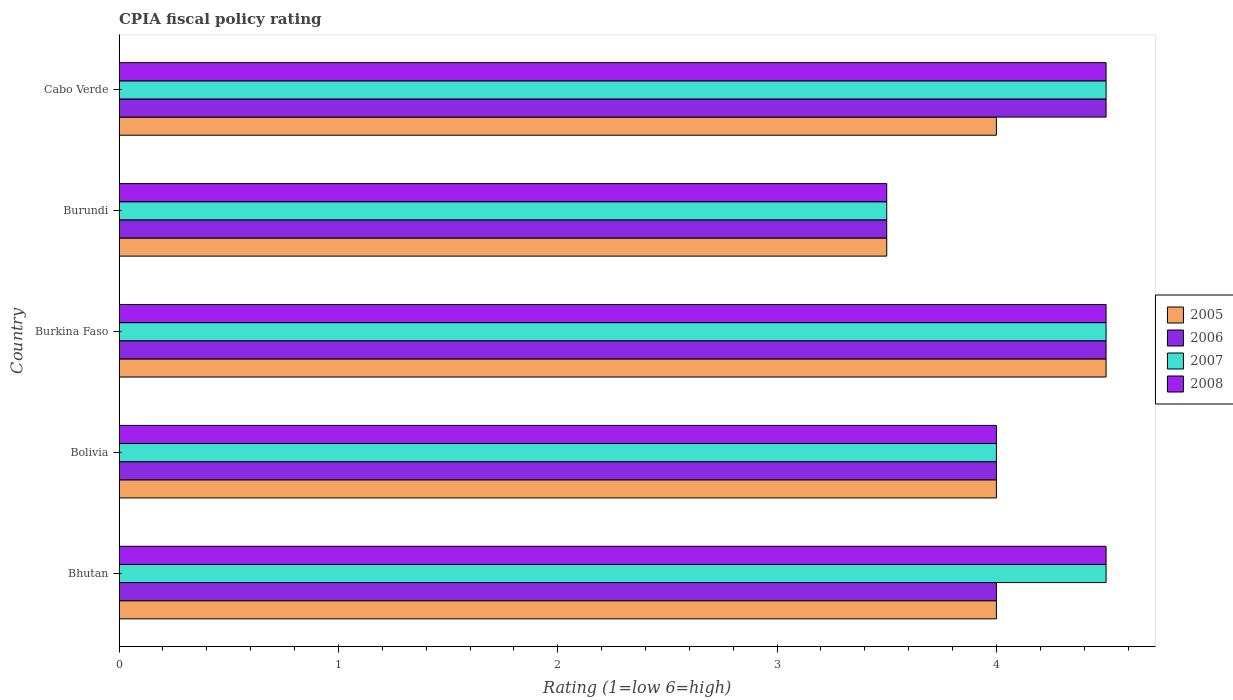How many different coloured bars are there?
Ensure brevity in your answer.  4. Are the number of bars on each tick of the Y-axis equal?
Offer a terse response. Yes. What is the label of the 1st group of bars from the top?
Your answer should be very brief. Cabo Verde. In which country was the CPIA rating in 2006 maximum?
Ensure brevity in your answer.  Burkina Faso. In which country was the CPIA rating in 2006 minimum?
Provide a succinct answer. Burundi. What is the total CPIA rating in 2005 in the graph?
Provide a short and direct response. 20. What is the difference between the CPIA rating in 2007 in Bolivia and the CPIA rating in 2008 in Bhutan?
Provide a succinct answer. -0.5. What is the difference between the CPIA rating in 2007 and CPIA rating in 2005 in Burkina Faso?
Offer a terse response. 0. In how many countries, is the CPIA rating in 2006 greater than 1.4 ?
Ensure brevity in your answer.  5. In how many countries, is the CPIA rating in 2005 greater than the average CPIA rating in 2005 taken over all countries?
Ensure brevity in your answer.  1. How many bars are there?
Offer a terse response. 20. What is the difference between two consecutive major ticks on the X-axis?
Provide a short and direct response. 1. Are the values on the major ticks of X-axis written in scientific E-notation?
Keep it short and to the point. No. What is the title of the graph?
Provide a succinct answer. CPIA fiscal policy rating. What is the label or title of the Y-axis?
Your response must be concise. Country. What is the Rating (1=low 6=high) in 2007 in Bhutan?
Keep it short and to the point. 4.5. What is the Rating (1=low 6=high) of 2006 in Bolivia?
Provide a succinct answer. 4. What is the Rating (1=low 6=high) of 2007 in Bolivia?
Your answer should be very brief. 4. What is the Rating (1=low 6=high) in 2005 in Burkina Faso?
Your answer should be compact. 4.5. What is the Rating (1=low 6=high) of 2006 in Burkina Faso?
Offer a very short reply. 4.5. What is the Rating (1=low 6=high) in 2006 in Burundi?
Provide a succinct answer. 3.5. What is the Rating (1=low 6=high) in 2007 in Burundi?
Offer a very short reply. 3.5. What is the Rating (1=low 6=high) in 2008 in Burundi?
Provide a short and direct response. 3.5. What is the Rating (1=low 6=high) of 2007 in Cabo Verde?
Provide a succinct answer. 4.5. Across all countries, what is the maximum Rating (1=low 6=high) in 2006?
Offer a terse response. 4.5. Across all countries, what is the maximum Rating (1=low 6=high) in 2007?
Provide a short and direct response. 4.5. Across all countries, what is the minimum Rating (1=low 6=high) of 2005?
Keep it short and to the point. 3.5. Across all countries, what is the minimum Rating (1=low 6=high) in 2006?
Offer a very short reply. 3.5. What is the total Rating (1=low 6=high) in 2007 in the graph?
Your answer should be very brief. 21. What is the difference between the Rating (1=low 6=high) of 2005 in Bhutan and that in Bolivia?
Make the answer very short. 0. What is the difference between the Rating (1=low 6=high) in 2008 in Bhutan and that in Bolivia?
Your answer should be very brief. 0.5. What is the difference between the Rating (1=low 6=high) in 2006 in Bhutan and that in Burkina Faso?
Provide a succinct answer. -0.5. What is the difference between the Rating (1=low 6=high) of 2008 in Bhutan and that in Burkina Faso?
Provide a succinct answer. 0. What is the difference between the Rating (1=low 6=high) in 2005 in Bhutan and that in Burundi?
Your response must be concise. 0.5. What is the difference between the Rating (1=low 6=high) in 2008 in Bhutan and that in Burundi?
Offer a very short reply. 1. What is the difference between the Rating (1=low 6=high) of 2007 in Bhutan and that in Cabo Verde?
Give a very brief answer. 0. What is the difference between the Rating (1=low 6=high) of 2007 in Bolivia and that in Burkina Faso?
Provide a short and direct response. -0.5. What is the difference between the Rating (1=low 6=high) in 2008 in Bolivia and that in Burkina Faso?
Provide a short and direct response. -0.5. What is the difference between the Rating (1=low 6=high) of 2006 in Bolivia and that in Burundi?
Provide a short and direct response. 0.5. What is the difference between the Rating (1=low 6=high) in 2007 in Bolivia and that in Burundi?
Make the answer very short. 0.5. What is the difference between the Rating (1=low 6=high) of 2008 in Bolivia and that in Burundi?
Your answer should be compact. 0.5. What is the difference between the Rating (1=low 6=high) in 2006 in Bolivia and that in Cabo Verde?
Offer a terse response. -0.5. What is the difference between the Rating (1=low 6=high) of 2008 in Bolivia and that in Cabo Verde?
Your response must be concise. -0.5. What is the difference between the Rating (1=low 6=high) of 2007 in Burkina Faso and that in Burundi?
Your answer should be compact. 1. What is the difference between the Rating (1=low 6=high) of 2005 in Burundi and that in Cabo Verde?
Your answer should be compact. -0.5. What is the difference between the Rating (1=low 6=high) in 2006 in Burundi and that in Cabo Verde?
Provide a short and direct response. -1. What is the difference between the Rating (1=low 6=high) in 2005 in Bhutan and the Rating (1=low 6=high) in 2006 in Bolivia?
Your answer should be very brief. 0. What is the difference between the Rating (1=low 6=high) in 2007 in Bhutan and the Rating (1=low 6=high) in 2008 in Bolivia?
Your answer should be very brief. 0.5. What is the difference between the Rating (1=low 6=high) in 2005 in Bhutan and the Rating (1=low 6=high) in 2007 in Burkina Faso?
Keep it short and to the point. -0.5. What is the difference between the Rating (1=low 6=high) of 2005 in Bhutan and the Rating (1=low 6=high) of 2008 in Burkina Faso?
Offer a very short reply. -0.5. What is the difference between the Rating (1=low 6=high) of 2007 in Bhutan and the Rating (1=low 6=high) of 2008 in Burkina Faso?
Your answer should be very brief. 0. What is the difference between the Rating (1=low 6=high) of 2005 in Bhutan and the Rating (1=low 6=high) of 2006 in Burundi?
Keep it short and to the point. 0.5. What is the difference between the Rating (1=low 6=high) in 2005 in Bhutan and the Rating (1=low 6=high) in 2007 in Burundi?
Ensure brevity in your answer.  0.5. What is the difference between the Rating (1=low 6=high) of 2005 in Bhutan and the Rating (1=low 6=high) of 2008 in Burundi?
Keep it short and to the point. 0.5. What is the difference between the Rating (1=low 6=high) in 2006 in Bhutan and the Rating (1=low 6=high) in 2007 in Burundi?
Make the answer very short. 0.5. What is the difference between the Rating (1=low 6=high) in 2005 in Bhutan and the Rating (1=low 6=high) in 2007 in Cabo Verde?
Offer a very short reply. -0.5. What is the difference between the Rating (1=low 6=high) in 2005 in Bhutan and the Rating (1=low 6=high) in 2008 in Cabo Verde?
Ensure brevity in your answer.  -0.5. What is the difference between the Rating (1=low 6=high) in 2006 in Bhutan and the Rating (1=low 6=high) in 2007 in Cabo Verde?
Make the answer very short. -0.5. What is the difference between the Rating (1=low 6=high) in 2006 in Bhutan and the Rating (1=low 6=high) in 2008 in Cabo Verde?
Provide a succinct answer. -0.5. What is the difference between the Rating (1=low 6=high) in 2007 in Bhutan and the Rating (1=low 6=high) in 2008 in Cabo Verde?
Your answer should be very brief. 0. What is the difference between the Rating (1=low 6=high) in 2005 in Bolivia and the Rating (1=low 6=high) in 2007 in Burkina Faso?
Your answer should be compact. -0.5. What is the difference between the Rating (1=low 6=high) of 2005 in Bolivia and the Rating (1=low 6=high) of 2008 in Burkina Faso?
Make the answer very short. -0.5. What is the difference between the Rating (1=low 6=high) in 2007 in Bolivia and the Rating (1=low 6=high) in 2008 in Burkina Faso?
Keep it short and to the point. -0.5. What is the difference between the Rating (1=low 6=high) in 2005 in Bolivia and the Rating (1=low 6=high) in 2006 in Burundi?
Provide a succinct answer. 0.5. What is the difference between the Rating (1=low 6=high) in 2006 in Bolivia and the Rating (1=low 6=high) in 2008 in Burundi?
Provide a short and direct response. 0.5. What is the difference between the Rating (1=low 6=high) of 2007 in Bolivia and the Rating (1=low 6=high) of 2008 in Burundi?
Provide a succinct answer. 0.5. What is the difference between the Rating (1=low 6=high) of 2005 in Bolivia and the Rating (1=low 6=high) of 2006 in Cabo Verde?
Make the answer very short. -0.5. What is the difference between the Rating (1=low 6=high) in 2005 in Bolivia and the Rating (1=low 6=high) in 2008 in Cabo Verde?
Give a very brief answer. -0.5. What is the difference between the Rating (1=low 6=high) of 2006 in Bolivia and the Rating (1=low 6=high) of 2007 in Cabo Verde?
Give a very brief answer. -0.5. What is the difference between the Rating (1=low 6=high) in 2006 in Bolivia and the Rating (1=low 6=high) in 2008 in Cabo Verde?
Keep it short and to the point. -0.5. What is the difference between the Rating (1=low 6=high) in 2005 in Burkina Faso and the Rating (1=low 6=high) in 2007 in Burundi?
Offer a terse response. 1. What is the difference between the Rating (1=low 6=high) of 2006 in Burkina Faso and the Rating (1=low 6=high) of 2007 in Burundi?
Offer a very short reply. 1. What is the difference between the Rating (1=low 6=high) in 2007 in Burkina Faso and the Rating (1=low 6=high) in 2008 in Burundi?
Your response must be concise. 1. What is the difference between the Rating (1=low 6=high) in 2005 in Burkina Faso and the Rating (1=low 6=high) in 2007 in Cabo Verde?
Give a very brief answer. 0. What is the difference between the Rating (1=low 6=high) in 2005 in Burkina Faso and the Rating (1=low 6=high) in 2008 in Cabo Verde?
Your response must be concise. 0. What is the difference between the Rating (1=low 6=high) of 2006 in Burkina Faso and the Rating (1=low 6=high) of 2007 in Cabo Verde?
Provide a succinct answer. 0. What is the difference between the Rating (1=low 6=high) in 2006 in Burkina Faso and the Rating (1=low 6=high) in 2008 in Cabo Verde?
Provide a succinct answer. 0. What is the difference between the Rating (1=low 6=high) in 2007 in Burkina Faso and the Rating (1=low 6=high) in 2008 in Cabo Verde?
Ensure brevity in your answer.  0. What is the difference between the Rating (1=low 6=high) in 2005 in Burundi and the Rating (1=low 6=high) in 2006 in Cabo Verde?
Offer a terse response. -1. What is the difference between the Rating (1=low 6=high) of 2006 in Burundi and the Rating (1=low 6=high) of 2008 in Cabo Verde?
Your answer should be compact. -1. What is the average Rating (1=low 6=high) of 2005 per country?
Your response must be concise. 4. What is the average Rating (1=low 6=high) of 2006 per country?
Provide a succinct answer. 4.1. What is the average Rating (1=low 6=high) in 2007 per country?
Provide a succinct answer. 4.2. What is the average Rating (1=low 6=high) in 2008 per country?
Give a very brief answer. 4.2. What is the difference between the Rating (1=low 6=high) in 2005 and Rating (1=low 6=high) in 2006 in Bhutan?
Provide a short and direct response. 0. What is the difference between the Rating (1=low 6=high) in 2006 and Rating (1=low 6=high) in 2008 in Bhutan?
Your answer should be very brief. -0.5. What is the difference between the Rating (1=low 6=high) of 2007 and Rating (1=low 6=high) of 2008 in Bhutan?
Provide a succinct answer. 0. What is the difference between the Rating (1=low 6=high) of 2005 and Rating (1=low 6=high) of 2006 in Bolivia?
Provide a short and direct response. 0. What is the difference between the Rating (1=low 6=high) in 2005 and Rating (1=low 6=high) in 2008 in Bolivia?
Your answer should be compact. 0. What is the difference between the Rating (1=low 6=high) of 2006 and Rating (1=low 6=high) of 2008 in Bolivia?
Keep it short and to the point. 0. What is the difference between the Rating (1=low 6=high) in 2007 and Rating (1=low 6=high) in 2008 in Bolivia?
Give a very brief answer. 0. What is the difference between the Rating (1=low 6=high) in 2007 and Rating (1=low 6=high) in 2008 in Burkina Faso?
Offer a very short reply. 0. What is the difference between the Rating (1=low 6=high) of 2005 and Rating (1=low 6=high) of 2006 in Burundi?
Your answer should be compact. 0. What is the difference between the Rating (1=low 6=high) in 2006 and Rating (1=low 6=high) in 2007 in Burundi?
Your answer should be compact. 0. What is the difference between the Rating (1=low 6=high) in 2006 and Rating (1=low 6=high) in 2008 in Burundi?
Keep it short and to the point. 0. What is the difference between the Rating (1=low 6=high) of 2005 and Rating (1=low 6=high) of 2006 in Cabo Verde?
Provide a succinct answer. -0.5. What is the difference between the Rating (1=low 6=high) of 2005 and Rating (1=low 6=high) of 2007 in Cabo Verde?
Ensure brevity in your answer.  -0.5. What is the difference between the Rating (1=low 6=high) in 2006 and Rating (1=low 6=high) in 2007 in Cabo Verde?
Offer a terse response. 0. What is the difference between the Rating (1=low 6=high) in 2006 and Rating (1=low 6=high) in 2008 in Cabo Verde?
Provide a succinct answer. 0. What is the difference between the Rating (1=low 6=high) in 2007 and Rating (1=low 6=high) in 2008 in Cabo Verde?
Keep it short and to the point. 0. What is the ratio of the Rating (1=low 6=high) of 2006 in Bhutan to that in Bolivia?
Offer a terse response. 1. What is the ratio of the Rating (1=low 6=high) of 2007 in Bhutan to that in Bolivia?
Your answer should be compact. 1.12. What is the ratio of the Rating (1=low 6=high) of 2005 in Bhutan to that in Burkina Faso?
Provide a short and direct response. 0.89. What is the ratio of the Rating (1=low 6=high) in 2006 in Bhutan to that in Burkina Faso?
Make the answer very short. 0.89. What is the ratio of the Rating (1=low 6=high) of 2008 in Bhutan to that in Burkina Faso?
Your answer should be very brief. 1. What is the ratio of the Rating (1=low 6=high) of 2005 in Bhutan to that in Burundi?
Provide a short and direct response. 1.14. What is the ratio of the Rating (1=low 6=high) in 2006 in Bhutan to that in Burundi?
Give a very brief answer. 1.14. What is the ratio of the Rating (1=low 6=high) of 2008 in Bhutan to that in Burundi?
Give a very brief answer. 1.29. What is the ratio of the Rating (1=low 6=high) of 2007 in Bolivia to that in Burkina Faso?
Provide a short and direct response. 0.89. What is the ratio of the Rating (1=low 6=high) in 2005 in Bolivia to that in Burundi?
Make the answer very short. 1.14. What is the ratio of the Rating (1=low 6=high) in 2008 in Bolivia to that in Burundi?
Your answer should be very brief. 1.14. What is the ratio of the Rating (1=low 6=high) of 2006 in Bolivia to that in Cabo Verde?
Your answer should be compact. 0.89. What is the ratio of the Rating (1=low 6=high) of 2007 in Bolivia to that in Cabo Verde?
Offer a terse response. 0.89. What is the ratio of the Rating (1=low 6=high) of 2006 in Burkina Faso to that in Burundi?
Your answer should be compact. 1.29. What is the ratio of the Rating (1=low 6=high) in 2008 in Burkina Faso to that in Burundi?
Your answer should be compact. 1.29. What is the ratio of the Rating (1=low 6=high) in 2005 in Burkina Faso to that in Cabo Verde?
Your answer should be compact. 1.12. What is the ratio of the Rating (1=low 6=high) of 2007 in Burkina Faso to that in Cabo Verde?
Offer a very short reply. 1. What is the ratio of the Rating (1=low 6=high) in 2008 in Burundi to that in Cabo Verde?
Offer a terse response. 0.78. What is the difference between the highest and the second highest Rating (1=low 6=high) of 2005?
Provide a succinct answer. 0.5. What is the difference between the highest and the second highest Rating (1=low 6=high) of 2006?
Your response must be concise. 0. What is the difference between the highest and the second highest Rating (1=low 6=high) of 2007?
Offer a terse response. 0. What is the difference between the highest and the second highest Rating (1=low 6=high) in 2008?
Your answer should be compact. 0. What is the difference between the highest and the lowest Rating (1=low 6=high) in 2005?
Your answer should be compact. 1. What is the difference between the highest and the lowest Rating (1=low 6=high) of 2006?
Make the answer very short. 1. 